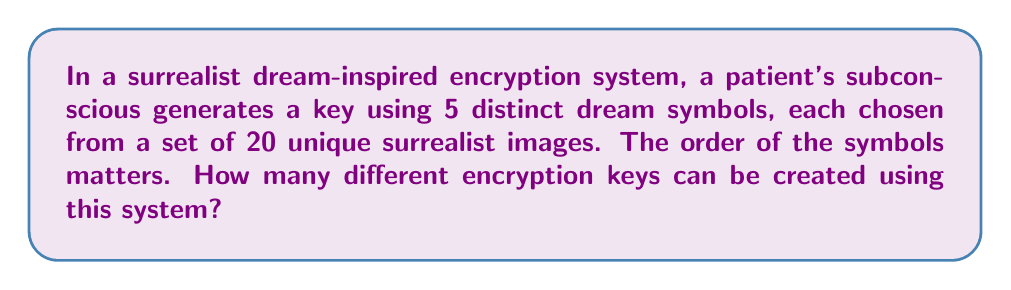Can you answer this question? To solve this problem, we'll use the concept of permutations without repetition:

1. We have 20 unique surrealist images to choose from.
2. We need to select 5 distinct symbols.
3. The order of the symbols matters.

This scenario is a perfect application of the permutation formula:

$$P(n,r) = \frac{n!}{(n-r)!}$$

Where:
$n$ = total number of items to choose from (20 surrealist images)
$r$ = number of items being chosen (5 symbols)

Let's plug in the values:

$$P(20,5) = \frac{20!}{(20-5)!} = \frac{20!}{15!}$$

Expanding this:

$$\frac{20 \cdot 19 \cdot 18 \cdot 17 \cdot 16 \cdot 15!}{15!}$$

The 15! cancels out in the numerator and denominator:

$$20 \cdot 19 \cdot 18 \cdot 17 \cdot 16 = 1,860,480$$

Therefore, there are 1,860,480 possible different encryption keys that can be created using this surrealist dream-inspired system.
Answer: 1,860,480 